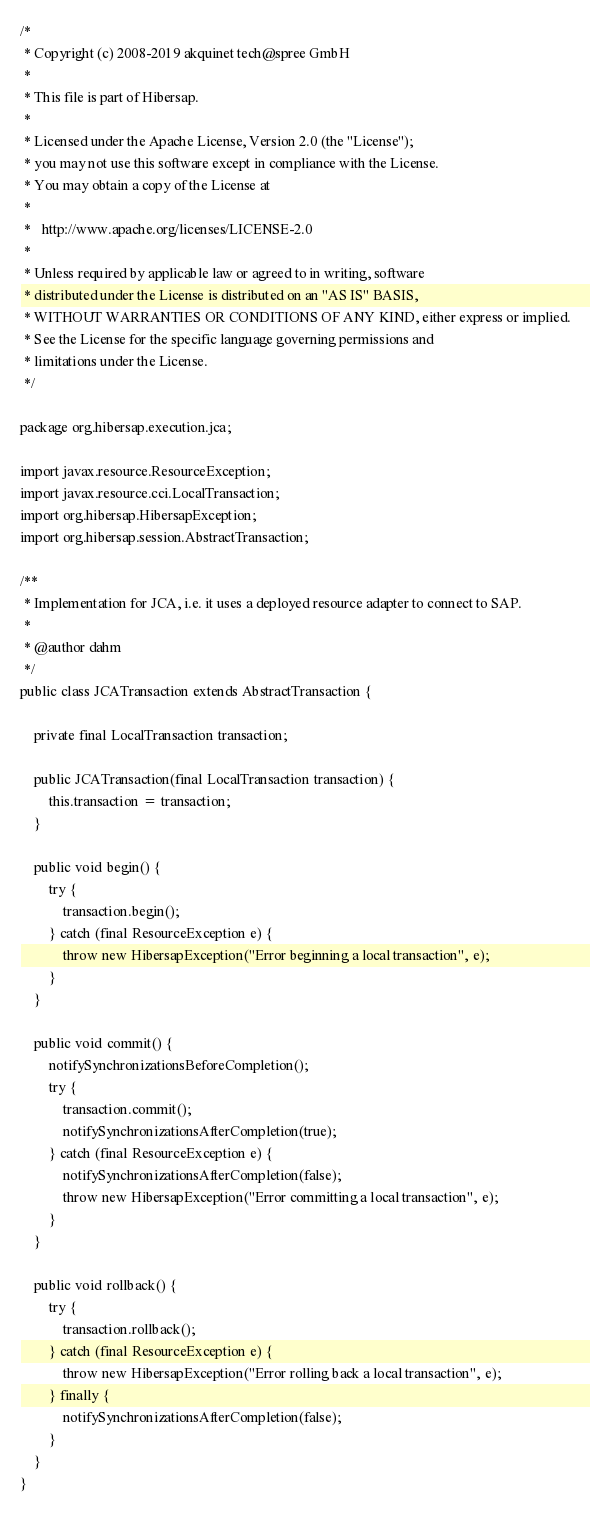<code> <loc_0><loc_0><loc_500><loc_500><_Java_>/*
 * Copyright (c) 2008-2019 akquinet tech@spree GmbH
 *
 * This file is part of Hibersap.
 *
 * Licensed under the Apache License, Version 2.0 (the "License");
 * you may not use this software except in compliance with the License.
 * You may obtain a copy of the License at
 *
 *   http://www.apache.org/licenses/LICENSE-2.0
 *
 * Unless required by applicable law or agreed to in writing, software
 * distributed under the License is distributed on an "AS IS" BASIS,
 * WITHOUT WARRANTIES OR CONDITIONS OF ANY KIND, either express or implied.
 * See the License for the specific language governing permissions and
 * limitations under the License.
 */

package org.hibersap.execution.jca;

import javax.resource.ResourceException;
import javax.resource.cci.LocalTransaction;
import org.hibersap.HibersapException;
import org.hibersap.session.AbstractTransaction;

/**
 * Implementation for JCA, i.e. it uses a deployed resource adapter to connect to SAP.
 *
 * @author dahm
 */
public class JCATransaction extends AbstractTransaction {

    private final LocalTransaction transaction;

    public JCATransaction(final LocalTransaction transaction) {
        this.transaction = transaction;
    }

    public void begin() {
        try {
            transaction.begin();
        } catch (final ResourceException e) {
            throw new HibersapException("Error beginning a local transaction", e);
        }
    }

    public void commit() {
        notifySynchronizationsBeforeCompletion();
        try {
            transaction.commit();
            notifySynchronizationsAfterCompletion(true);
        } catch (final ResourceException e) {
            notifySynchronizationsAfterCompletion(false);
            throw new HibersapException("Error committing a local transaction", e);
        }
    }

    public void rollback() {
        try {
            transaction.rollback();
        } catch (final ResourceException e) {
            throw new HibersapException("Error rolling back a local transaction", e);
        } finally {
            notifySynchronizationsAfterCompletion(false);
        }
    }
}
</code> 